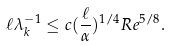<formula> <loc_0><loc_0><loc_500><loc_500>\ell \lambda _ { k } ^ { - 1 } \leq c ( \frac { \ell } { \alpha } ) ^ { 1 / 4 } R e ^ { 5 / 8 } .</formula> 